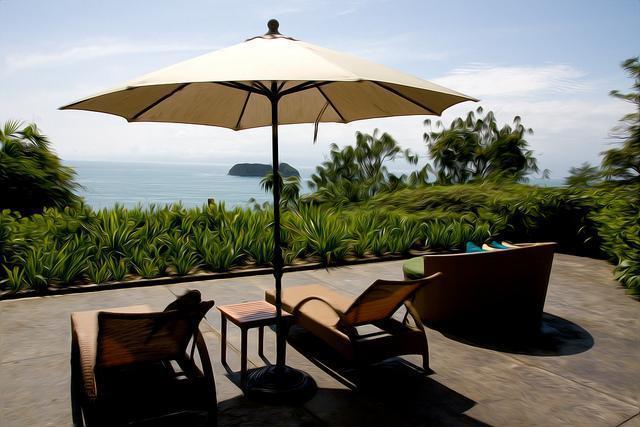How many chairs are there?
Give a very brief answer. 3. How many chairs can be seen?
Give a very brief answer. 3. How many chairs are visible?
Give a very brief answer. 3. 